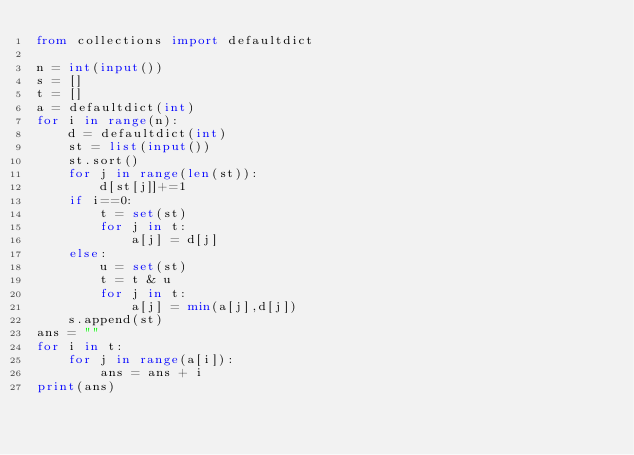Convert code to text. <code><loc_0><loc_0><loc_500><loc_500><_Python_>from collections import defaultdict

n = int(input())
s = []
t = []
a = defaultdict(int)
for i in range(n):
    d = defaultdict(int)
    st = list(input())
    st.sort()
    for j in range(len(st)):
        d[st[j]]+=1    
    if i==0:
        t = set(st)
        for j in t:
            a[j] = d[j]
    else:
        u = set(st)
        t = t & u 
        for j in t:
            a[j] = min(a[j],d[j])
    s.append(st)
ans = ""
for i in t:
    for j in range(a[i]):
        ans = ans + i
print(ans)</code> 